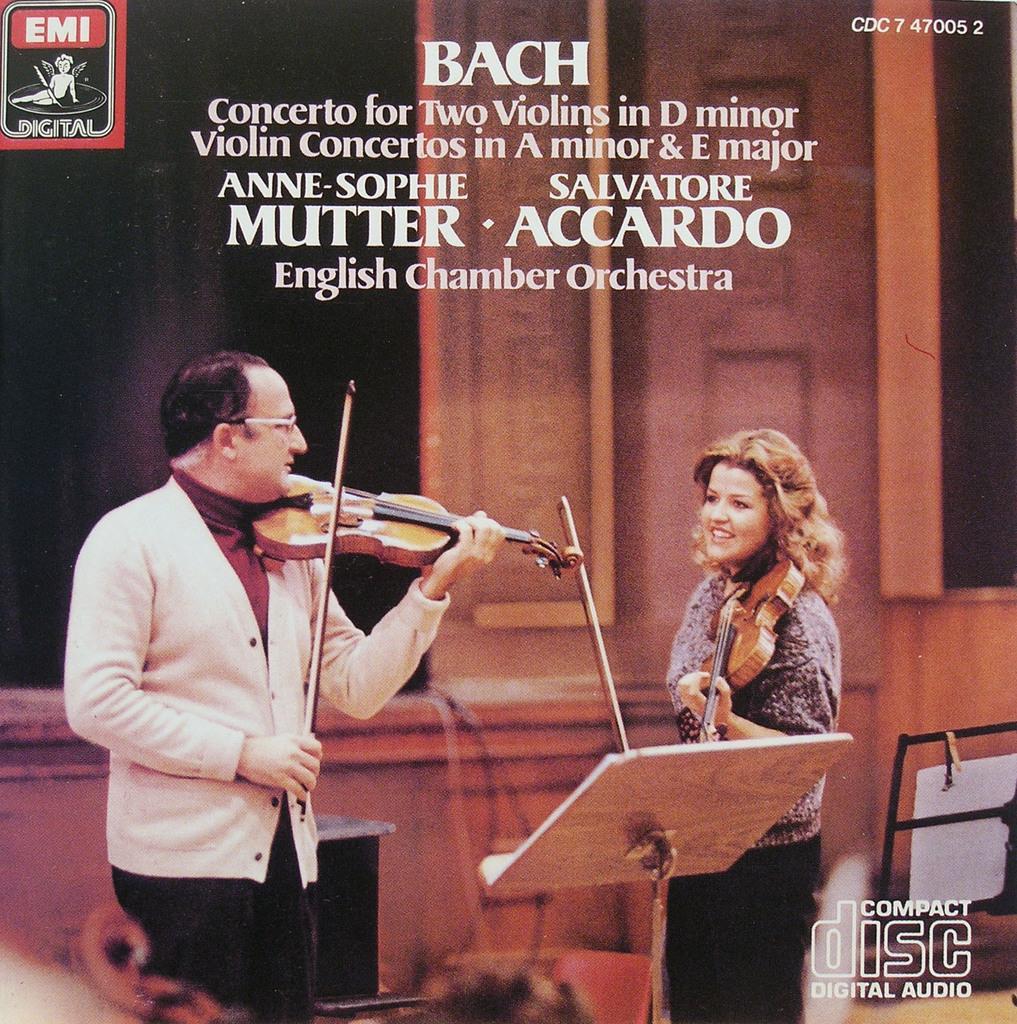Please provide a concise description of this image. In the picture there are two person standing and playing violin with the table in front of them there is a wall near to them on the picture there is some text. 